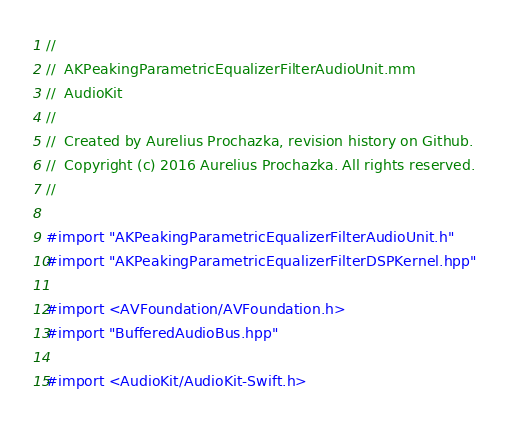Convert code to text. <code><loc_0><loc_0><loc_500><loc_500><_ObjectiveC_>//
//  AKPeakingParametricEqualizerFilterAudioUnit.mm
//  AudioKit
//
//  Created by Aurelius Prochazka, revision history on Github.
//  Copyright (c) 2016 Aurelius Prochazka. All rights reserved.
//

#import "AKPeakingParametricEqualizerFilterAudioUnit.h"
#import "AKPeakingParametricEqualizerFilterDSPKernel.hpp"

#import <AVFoundation/AVFoundation.h>
#import "BufferedAudioBus.hpp"

#import <AudioKit/AudioKit-Swift.h>
</code> 